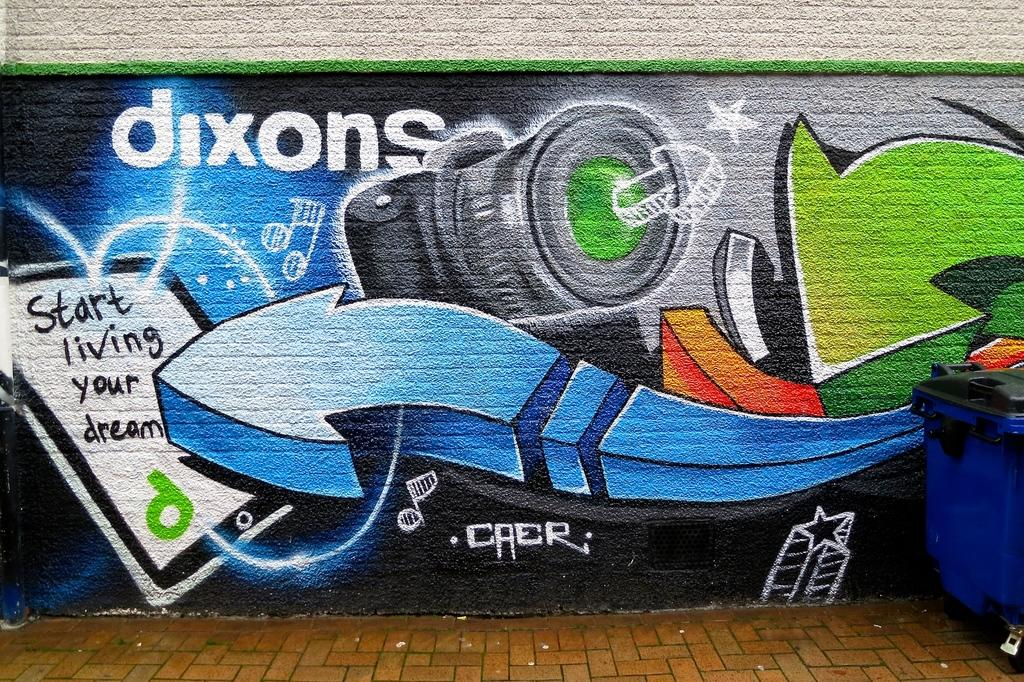<image>
Share a concise interpretation of the image provided. "Start living your dream" is painted on a brick wall. 